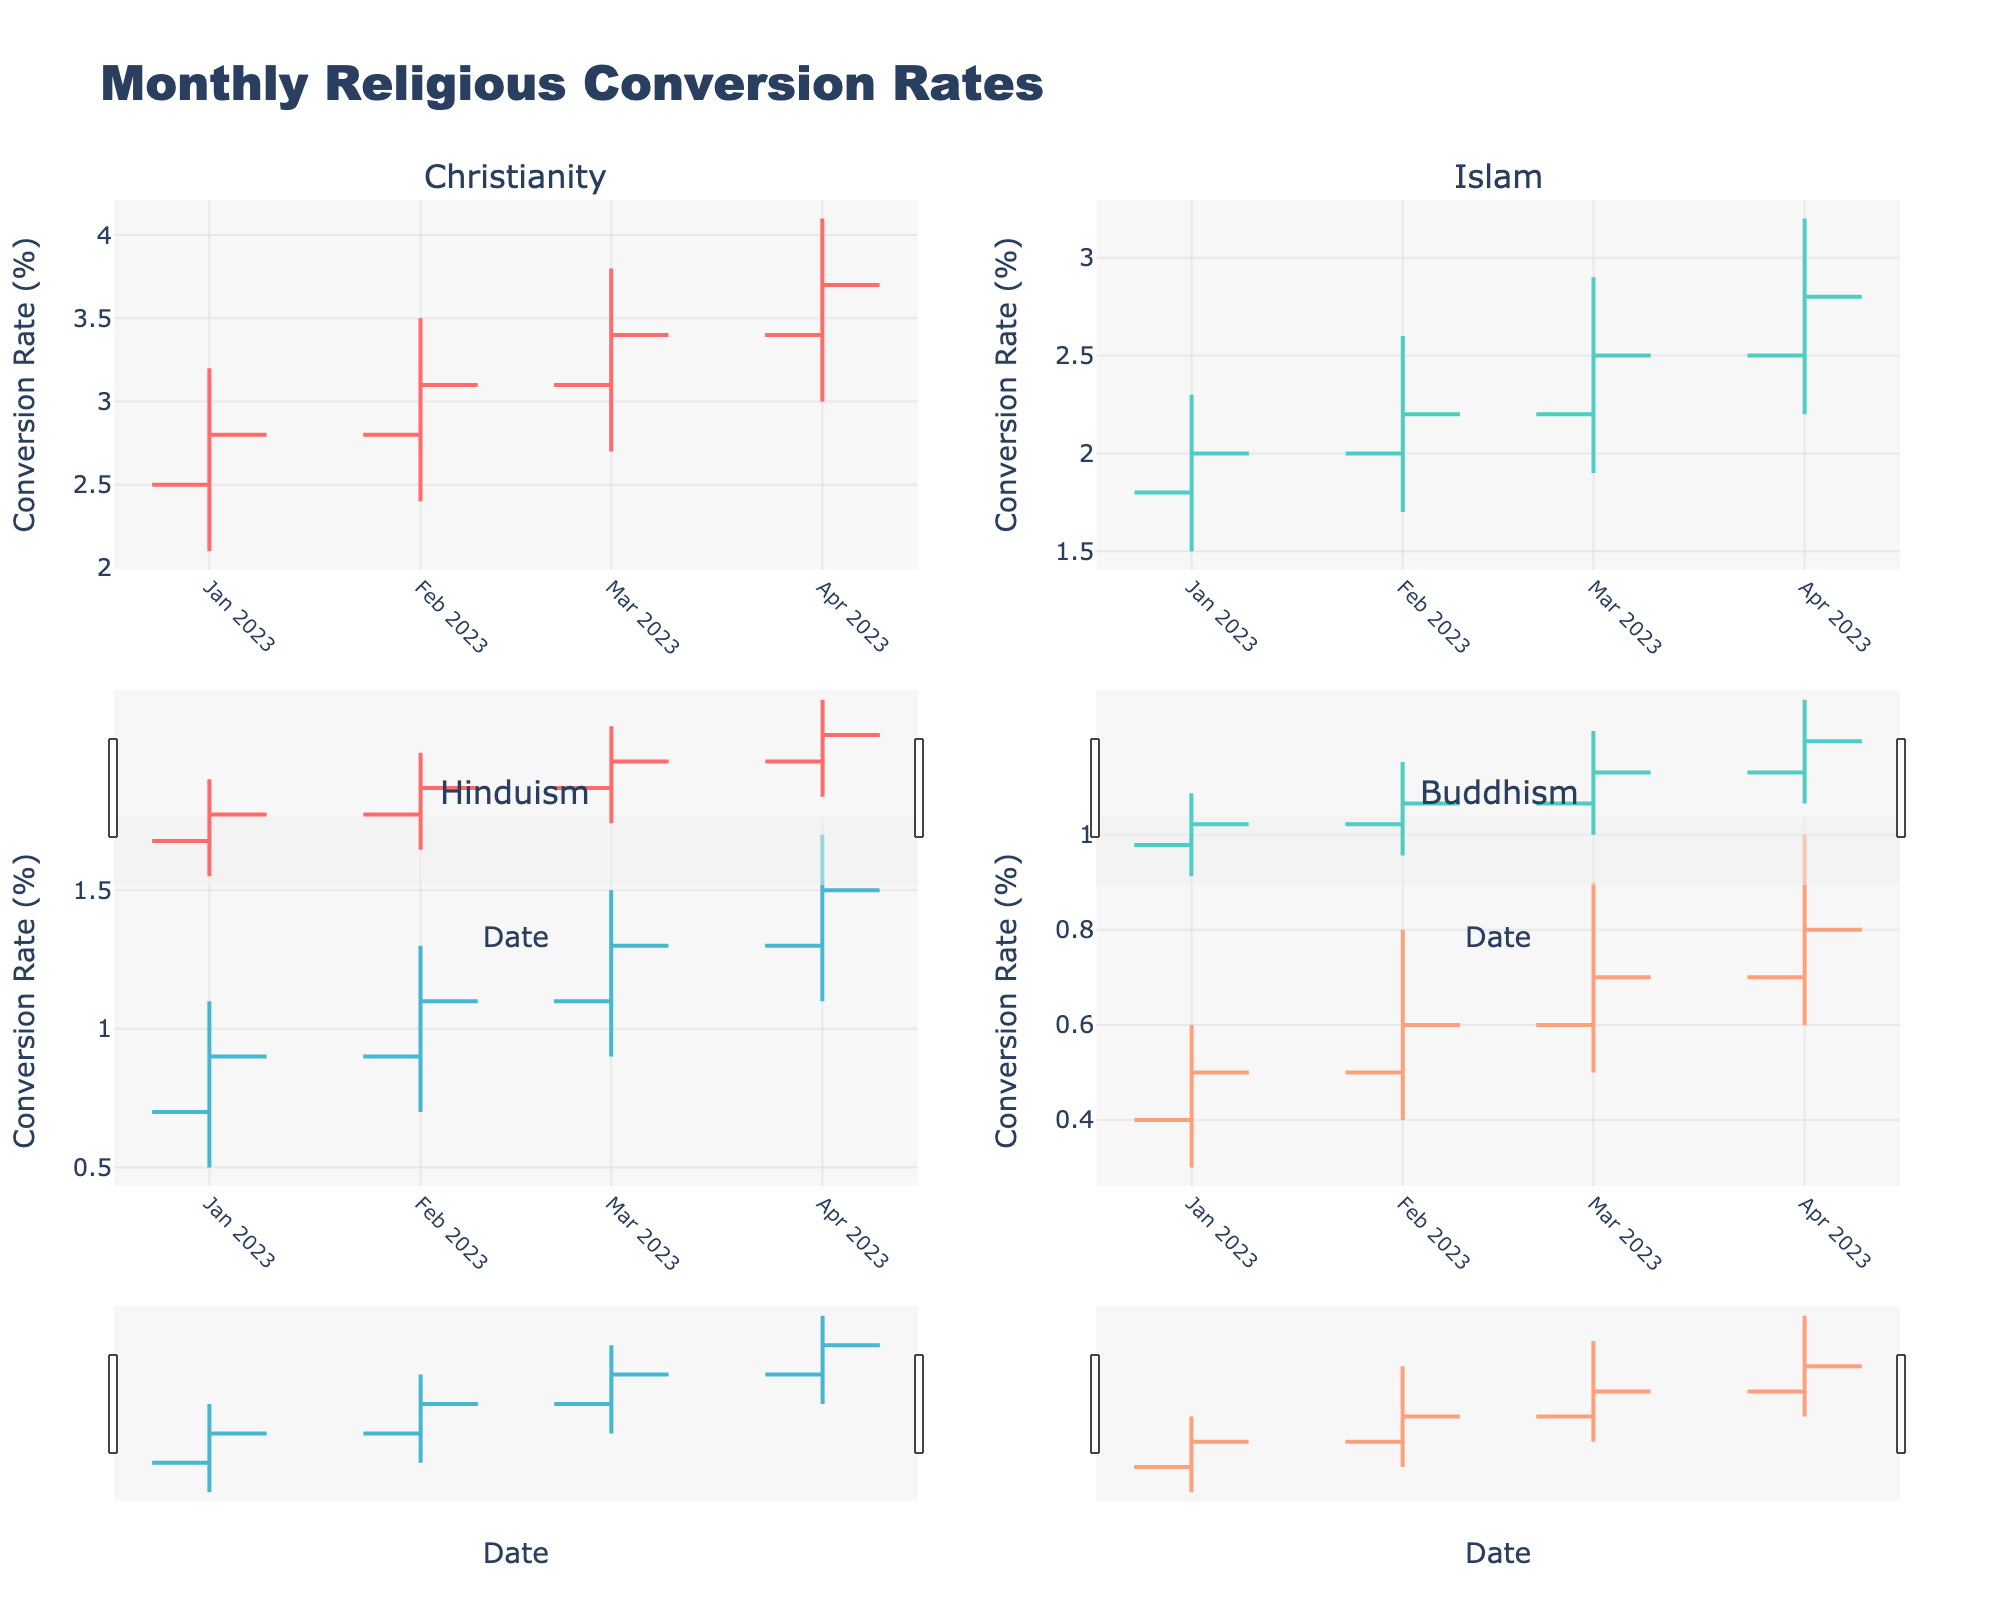What is the title of the figure? The title is usually displayed at the top of the chart. In this case, it indicates what the figure is about.
Answer: Monthly Religious Conversion Rates Which religion has the highest conversion rate in January 2023? By looking at the "High" value for each religion in January 2023, we can see which religion has the highest spike in conversion rate. Christianity has a high value of 3.2, which is the highest.
Answer: Christianity How does the conversion rate for Islam in February 2023 compare to March 2023? Check the "Close" values for Islam in February and March. In February, the close value is 2.2, and in March, it is 2.5, indicating an increase.
Answer: Increased What is the range of conversion rates for Buddhism in April 2023? The range can be found by subtracting the "Low" value from the "High" value for Buddhism in April 2023. The values are 1.0 (High) and 0.6 (Low), so the range is 1.0 - 0.6 = 0.4.
Answer: 0.4 Which month shows the highest closing conversion rate for Hinduism? Look at the "Close" values for Hinduism across all months to find the highest value. The highest is in April 2023, with a value of 1.5.
Answer: April 2023 How did the conversion rate for Christianity change from January 2023 to February 2023? Compare the "Close" values for Christianity in January and February. In January, it's 2.8, and in February it's 3.1. There is an increase of 3.1 - 2.8 = 0.3.
Answer: Increased by 0.3 Which religion has the most stable conversion rate over the four months? A stable rate would show less variation between the "Low" and "High" values. Buddhism shows relatively small ranges (0.3 to 0.4 on average), indicating stability.
Answer: Buddhism How do the conversion rates for Hinduism in March 2023 differ from those in January 2023? Compare both "High" and "Low" values along with the "Close" values. In January, the values are 1.1 (High), 0.5 (Low), and 0.9 (Close). In March, they are 1.5 (High), 0.9 (Low), 1.3 (Close). Each value increased.
Answer: Increased Among the religions, which one experienced the largest increase in conversion rate from the open to the close value in any given month? Calculate the difference between "Open" and "Close" values for all religions across months. The largest difference is for Christianity in April 2023, going from 3.4 (Open) to 3.7 (Close), i.e., 0.3.
Answer: Christianity in April 2023 In which month did Islam have the highest volatility (difference between High and Low values)? Check the range (difference) between "High" and "Low" values for Islam in each month. In April 2023, the values are 3.2 (High) and 2.2 (Low), with a difference of 1.0, which is the highest.
Answer: April 2023 